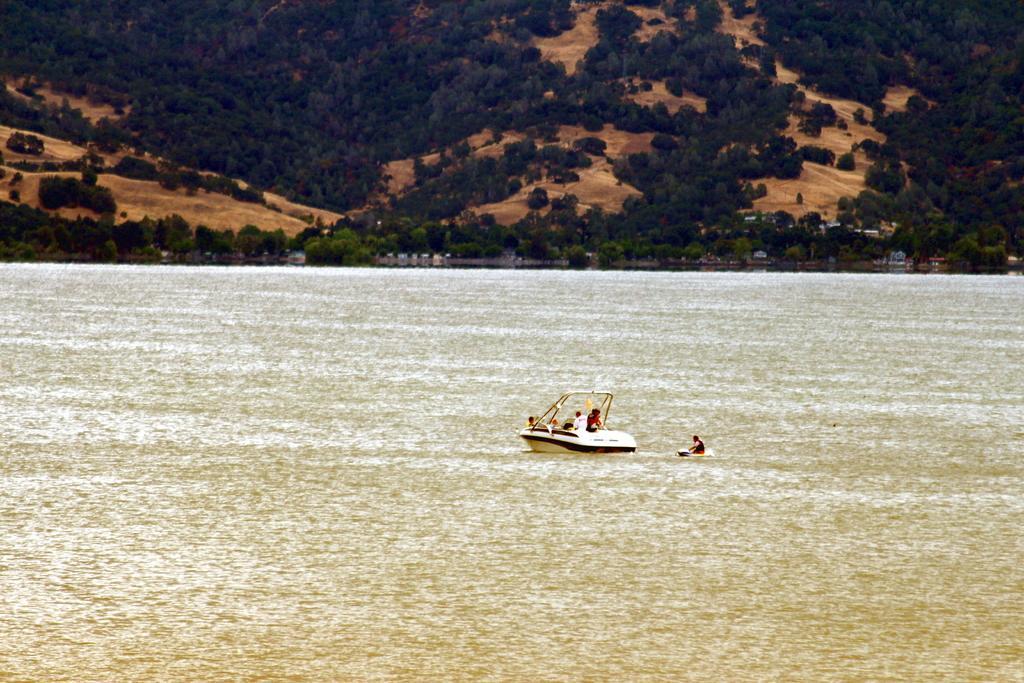In one or two sentences, can you explain what this image depicts? In the center of the image we can see persons sailing on the boat. In the background we can see water, trees and hill. 